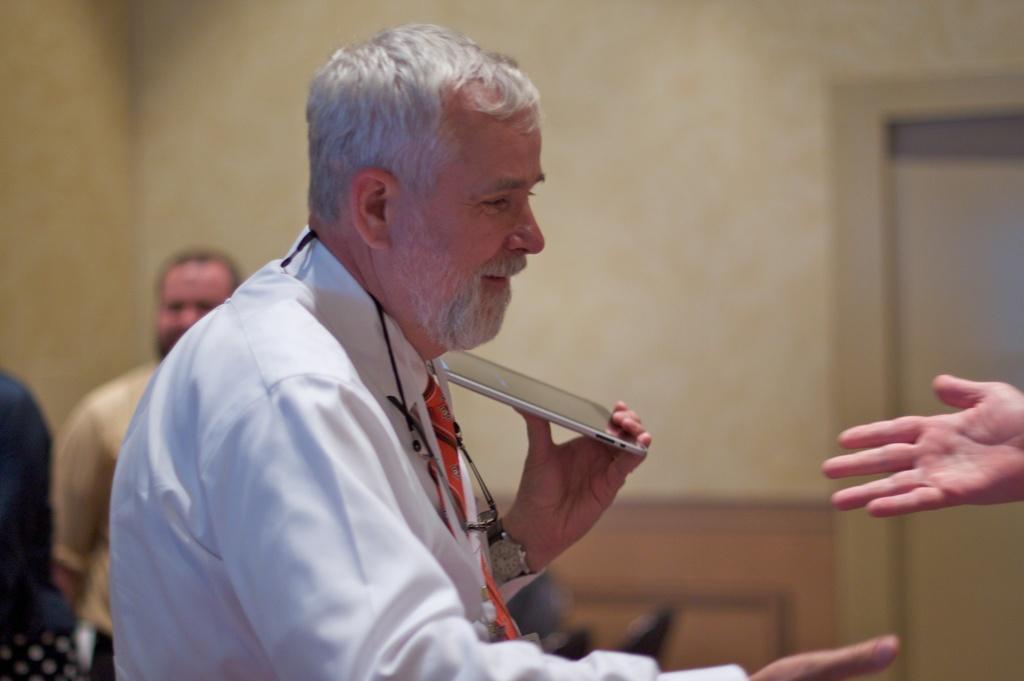Please provide a concise description of this image. On the left side, there is a person in a white color shirt, holding a tab with a hand, smiling and stretching other hand. On the right side, there is a person stretching his hand. In the background, there are two persons, there is a door and a wall. 